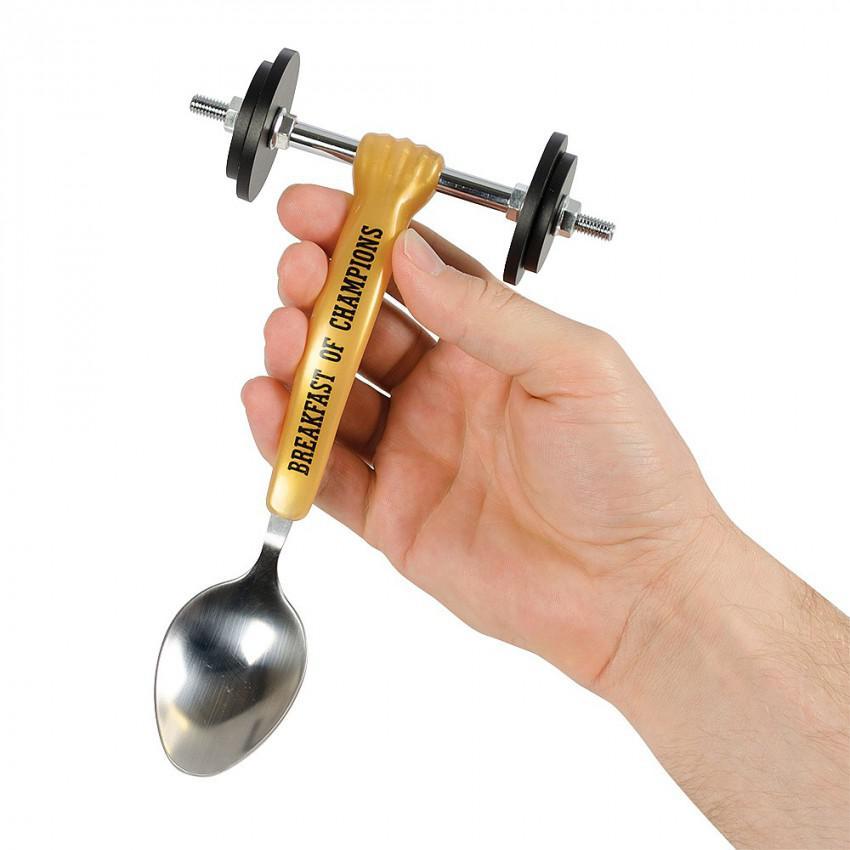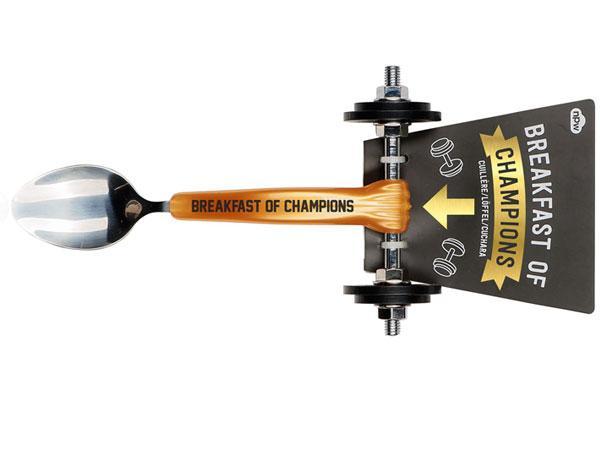The first image is the image on the left, the second image is the image on the right. Assess this claim about the two images: "there is a hand in one of the images". Correct or not? Answer yes or no. Yes. The first image is the image on the left, the second image is the image on the right. Assess this claim about the two images: "In one image, a fancy spoon with wheels is held in a hand.". Correct or not? Answer yes or no. Yes. 